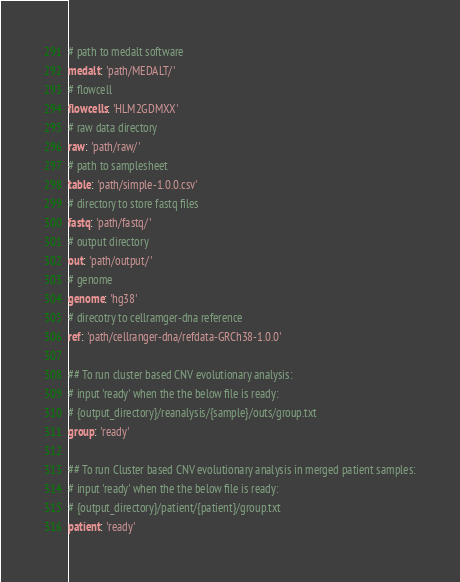Convert code to text. <code><loc_0><loc_0><loc_500><loc_500><_YAML_># path to medalt software
medalt: 'path/MEDALT/'
# flowcell
flowcells: 'HLM2GDMXX' 
# raw data directory
raw: 'path/raw/'
# path to samplesheet
table: 'path/simple-1.0.0.csv'
# directory to store fastq files
fastq: 'path/fastq/'
# output directory
out: 'path/output/'
# genome
genome: 'hg38'
# direcotry to cellramger-dna reference
ref: 'path/cellranger-dna/refdata-GRCh38-1.0.0'

## To run cluster based CNV evolutionary analysis:
# input 'ready' when the the below file is ready:
# {output_directory}/reanalysis/{sample}/outs/group.txt
group: 'ready' 

## To run Cluster based CNV evolutionary analysis in merged patient samples:
# input 'ready' when the the below file is ready:
# {output_directory}/patient/{patient}/group.txt
patient: 'ready'
</code> 